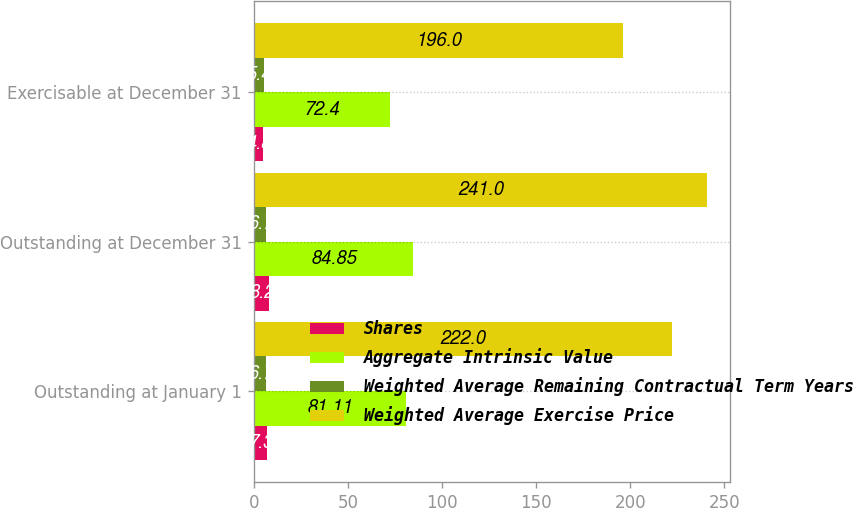Convert chart. <chart><loc_0><loc_0><loc_500><loc_500><stacked_bar_chart><ecel><fcel>Outstanding at January 1<fcel>Outstanding at December 31<fcel>Exercisable at December 31<nl><fcel>Shares<fcel>7.3<fcel>8.2<fcel>4.8<nl><fcel>Aggregate Intrinsic Value<fcel>81.11<fcel>84.85<fcel>72.4<nl><fcel>Weighted Average Remaining Contractual Term Years<fcel>6.7<fcel>6.7<fcel>5.4<nl><fcel>Weighted Average Exercise Price<fcel>222<fcel>241<fcel>196<nl></chart> 